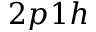Convert formula to latex. <formula><loc_0><loc_0><loc_500><loc_500>2 p 1 h</formula> 